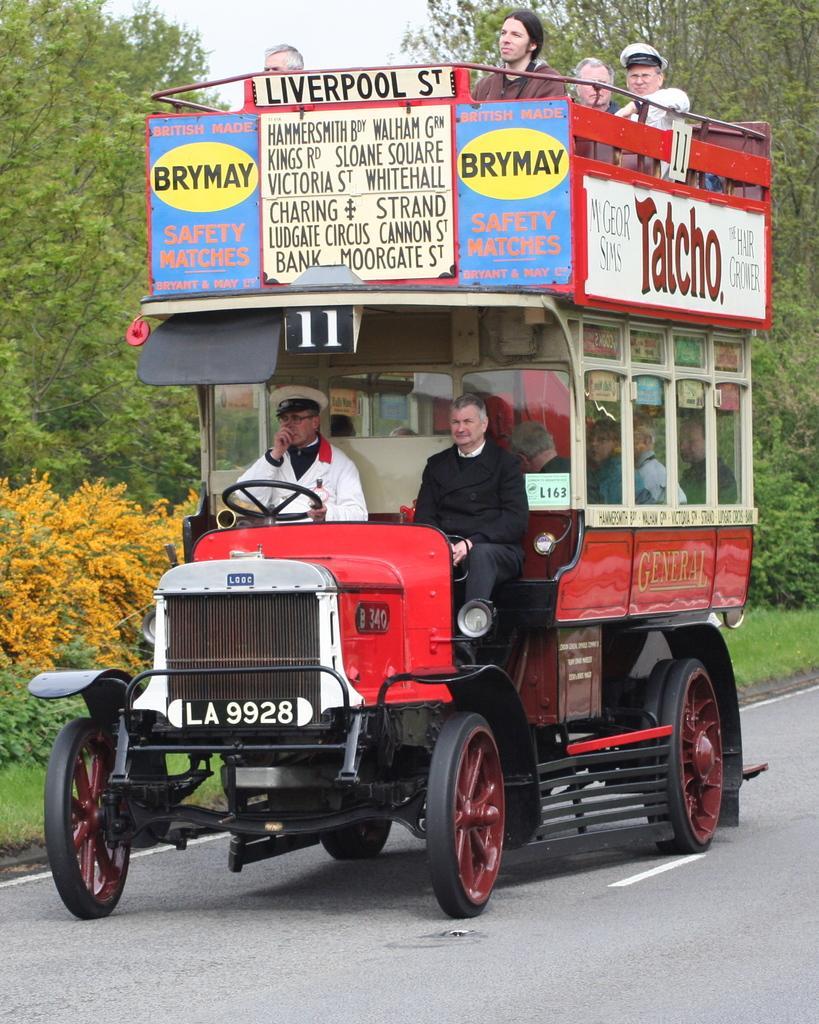Describe this image in one or two sentences. In the foreground I can see a person is driving a vehicle on the road, boards and a group of people. In the background grass, trees and the sky. This image is taken may be on the road. 